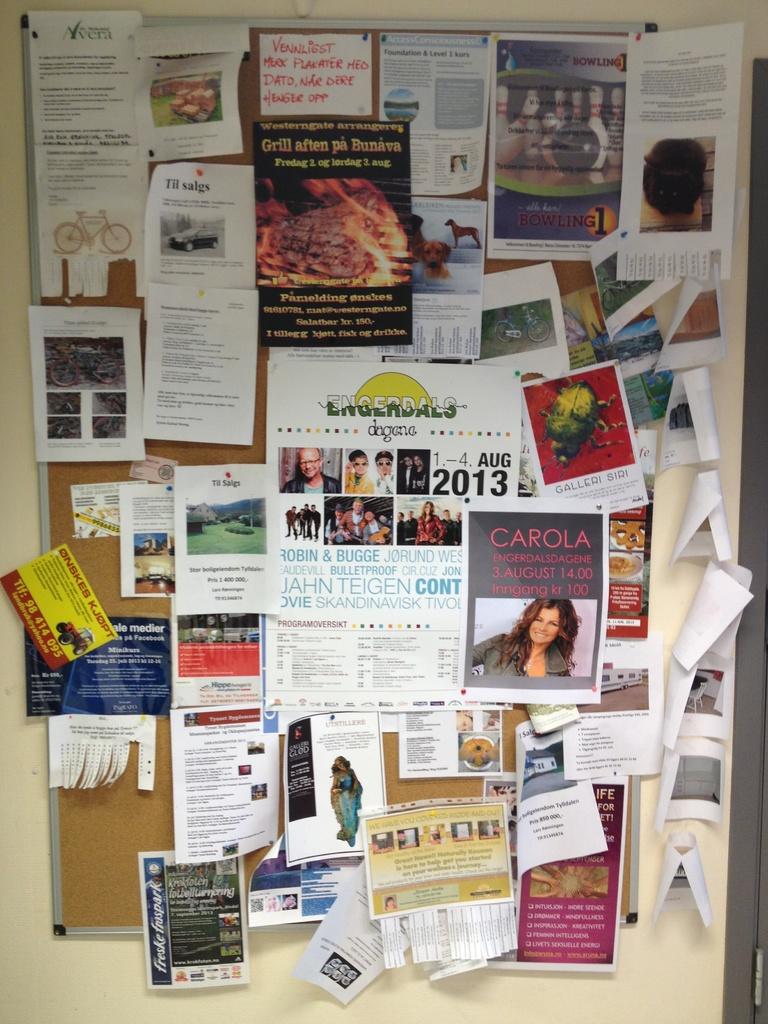Does that say 2013?
Provide a succinct answer. Yes. What is the womans name?
Provide a short and direct response. Carola. 